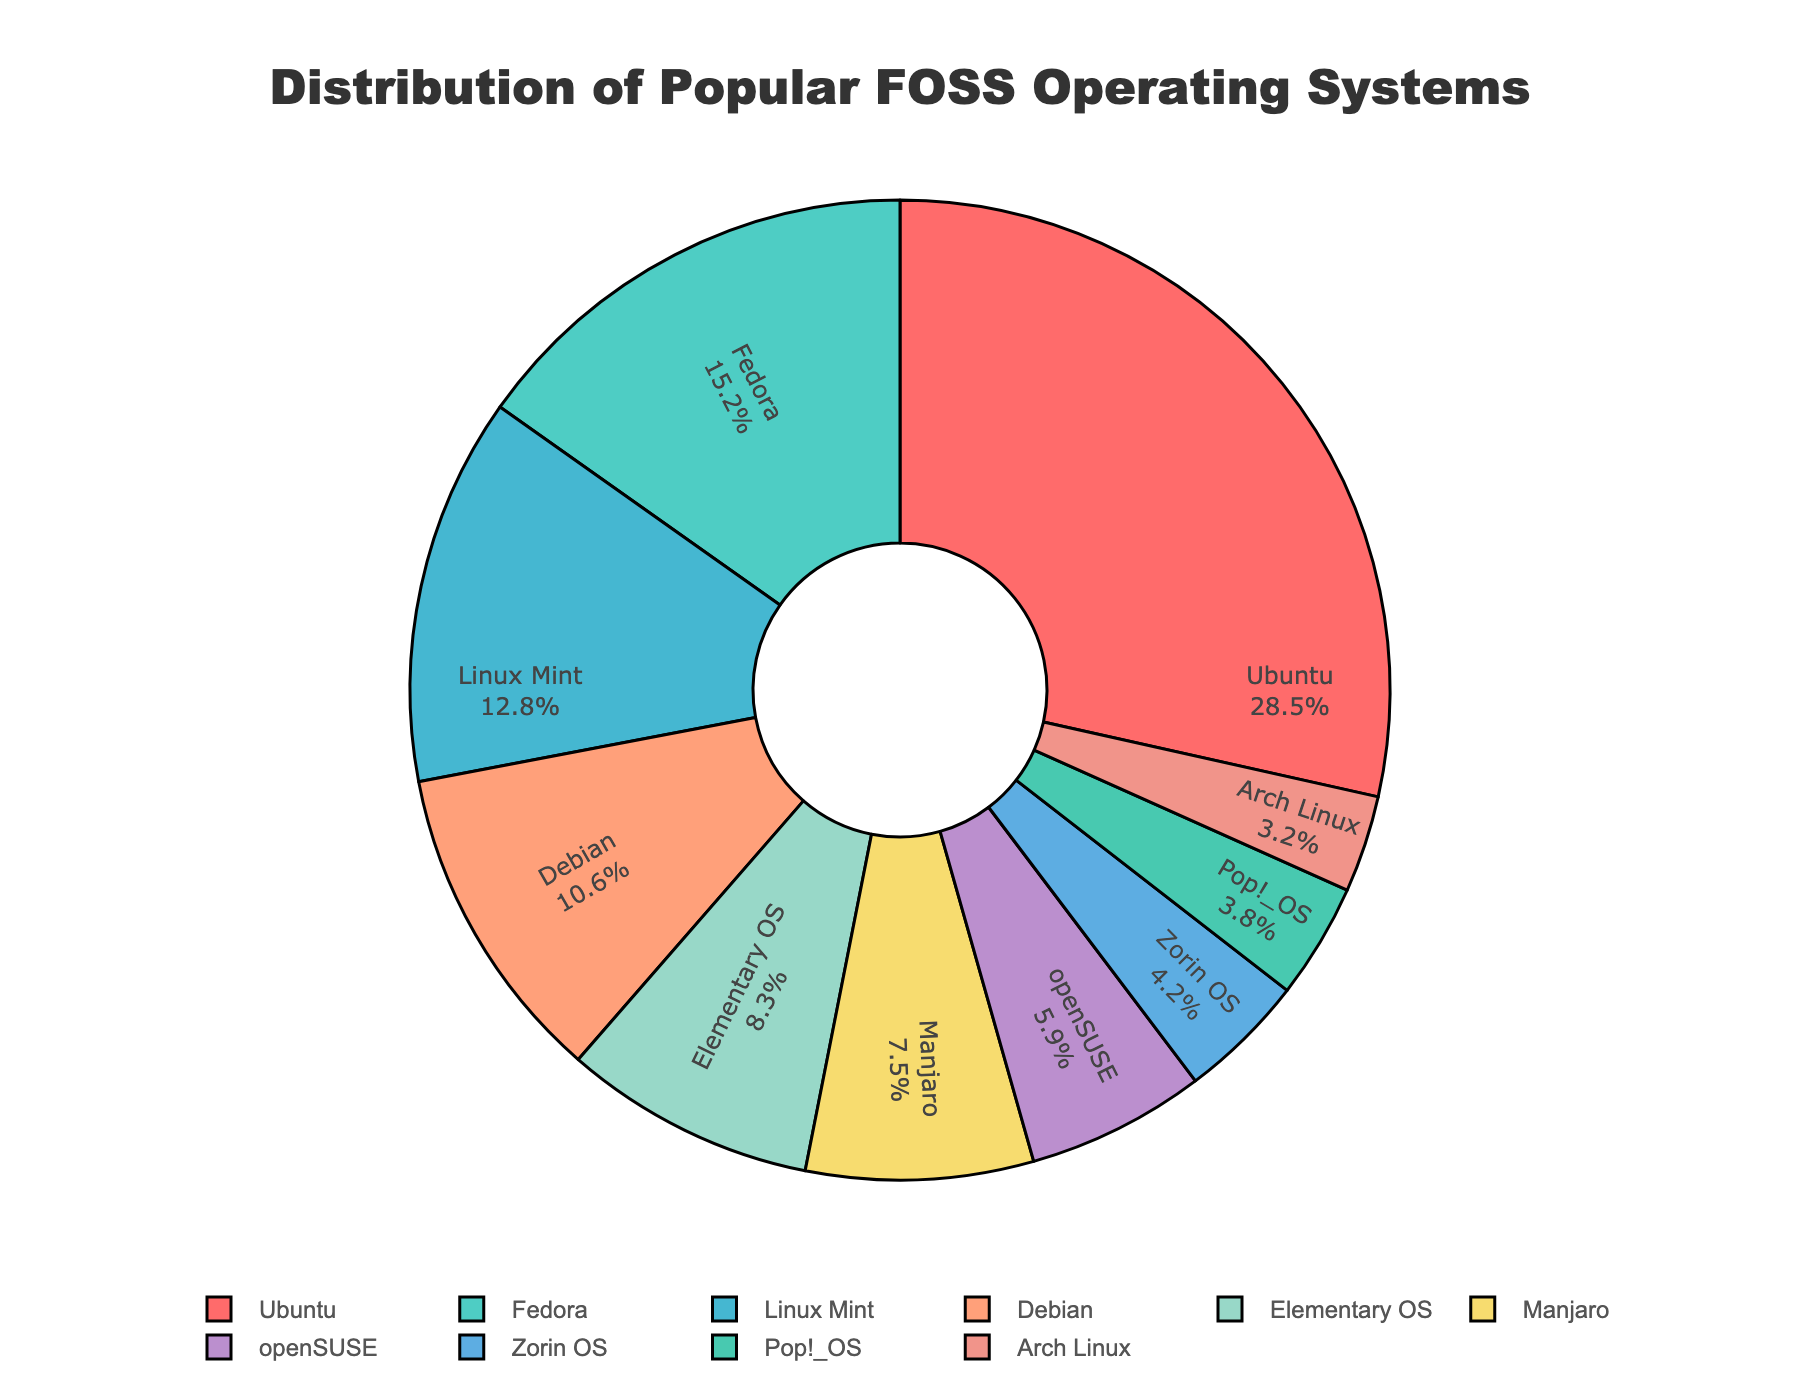What's the largest segment in the pie chart? The largest segment corresponds to the operating system with the highest percentage. From the chart, this is Ubuntu with 28.5%.
Answer: Ubuntu Which operating system has a percentage closest to 10%? By looking at the percentages, Debian is the operating system with a percentage closest to 10%, specifically 10.6%.
Answer: Debian What is the combined percentage of Fedora, Linux Mint, and Elementary OS? Add the percentages of Fedora (15.2%), Linux Mint (12.8%), and Elementary OS (8.3%): 15.2 + 12.8 + 8.3 = 36.3%.
Answer: 36.3% Which operating system has the smallest segment in the chart? The smallest segment corresponds to the operating system with the lowest percentage. From the chart, this is Arch Linux with 3.2%.
Answer: Arch Linux Compare the percentages of Manjaro and openSUSE. Which one is higher and by how much? Manjaro has 7.5% while openSUSE has 5.9%. To find the difference, subtract the smaller percentage from the larger one: 7.5 - 5.9 = 1.6%. Manjaro is higher by 1.6%.
Answer: Manjaro is higher by 1.6% What is the difference in percentage between Ubuntu and Pop!_OS? Subtract the percentage of Pop!_OS (3.8%) from Ubuntu (28.5%): 28.5 - 3.8 = 24.7%.
Answer: 24.7% Which two operating systems combined make up closest to 20%? Adding and checking the combinations: Linux Mint (12.8%) + Arch Linux (3.2%) = 16%, Elementary OS (8.3%) + Manjaro (7.5%) = 15.8%, Fedora (15.2%) + Zorin OS (4.2%) = 19.4%. The closest combination is Fedora and Zorin OS with 19.4%.
Answer: Fedora and Zorin OS Which segments have a yellowish or gold color? From the colors specified in the code, Elementary OS (orange/gold) and Manjaro (yellow/gold) have yellowish or gold colors.
Answer: Elementary OS and Manjaro What is the average percentage of all the operating systems combined? Sum all percentages: 28.5 + 15.2 + 12.8 + 10.6 + 8.3 + 7.5 + 5.9 + 4.2 + 3.8 + 3.2 = 100%. There are 10 operating systems. The average is 100% / 10 = 10%.
Answer: 10% Which operating systems have percentages greater than 10%? Operating systems with percentages greater than 10% are Ubuntu (28.5%), Fedora (15.2%), Linux Mint (12.8%), and Debian (10.6%).
Answer: Ubuntu, Fedora, Linux Mint, Debian 